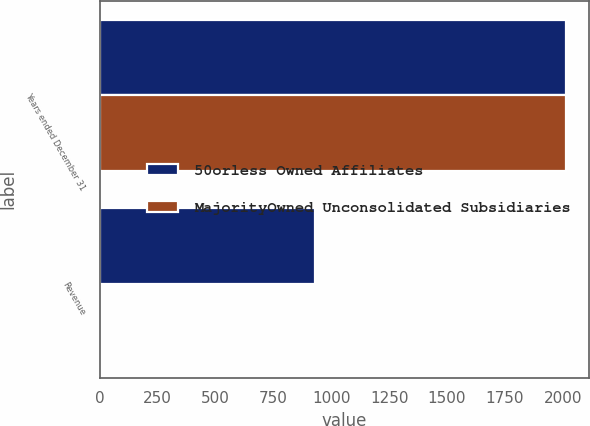<chart> <loc_0><loc_0><loc_500><loc_500><stacked_bar_chart><ecel><fcel>Years ended December 31<fcel>Revenue<nl><fcel>50orless Owned Affiliates<fcel>2014<fcel>928<nl><fcel>MajorityOwned Unconsolidated Subsidiaries<fcel>2014<fcel>2<nl></chart> 